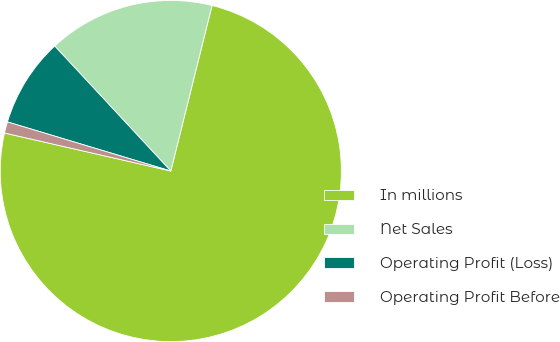<chart> <loc_0><loc_0><loc_500><loc_500><pie_chart><fcel>In millions<fcel>Net Sales<fcel>Operating Profit (Loss)<fcel>Operating Profit Before<nl><fcel>74.69%<fcel>15.8%<fcel>8.44%<fcel>1.07%<nl></chart> 